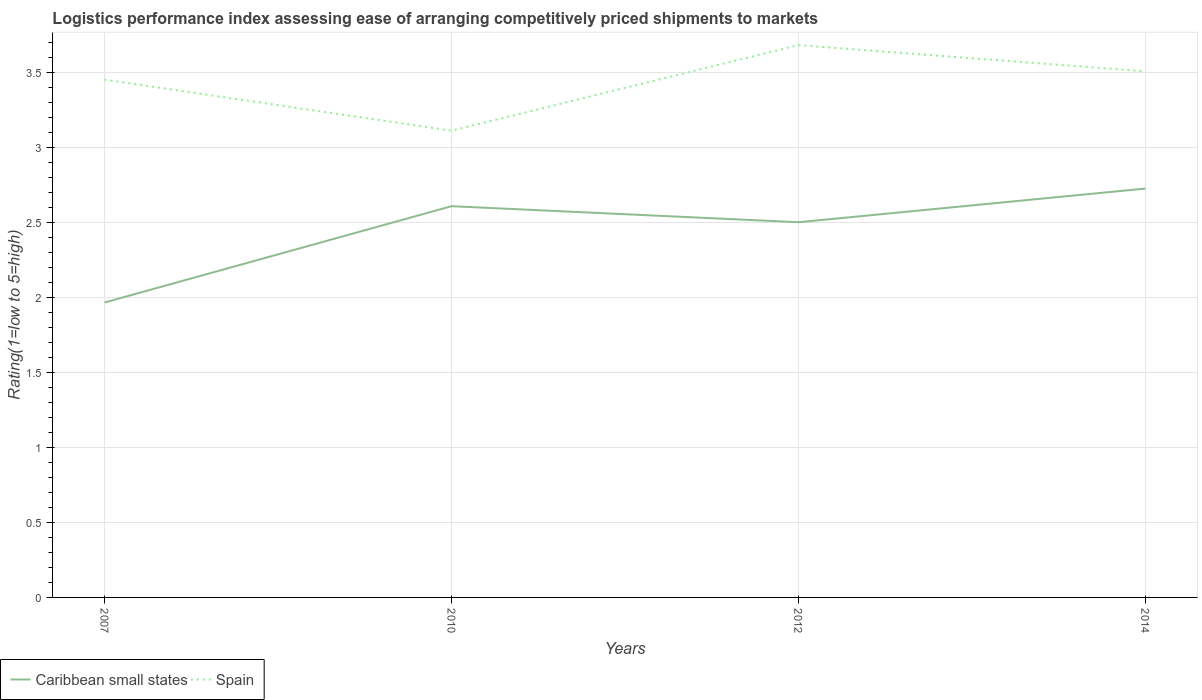How many different coloured lines are there?
Ensure brevity in your answer.  2. Is the number of lines equal to the number of legend labels?
Offer a very short reply. Yes. Across all years, what is the maximum Logistic performance index in Spain?
Ensure brevity in your answer.  3.11. In which year was the Logistic performance index in Spain maximum?
Offer a terse response. 2010. What is the total Logistic performance index in Caribbean small states in the graph?
Your answer should be compact. -0.22. What is the difference between the highest and the second highest Logistic performance index in Caribbean small states?
Your answer should be compact. 0.76. What is the difference between the highest and the lowest Logistic performance index in Caribbean small states?
Offer a very short reply. 3. Is the Logistic performance index in Spain strictly greater than the Logistic performance index in Caribbean small states over the years?
Make the answer very short. No. Are the values on the major ticks of Y-axis written in scientific E-notation?
Give a very brief answer. No. Where does the legend appear in the graph?
Ensure brevity in your answer.  Bottom left. How many legend labels are there?
Provide a short and direct response. 2. How are the legend labels stacked?
Provide a succinct answer. Horizontal. What is the title of the graph?
Give a very brief answer. Logistics performance index assessing ease of arranging competitively priced shipments to markets. Does "Puerto Rico" appear as one of the legend labels in the graph?
Provide a short and direct response. No. What is the label or title of the X-axis?
Provide a succinct answer. Years. What is the label or title of the Y-axis?
Offer a terse response. Rating(1=low to 5=high). What is the Rating(1=low to 5=high) in Caribbean small states in 2007?
Make the answer very short. 1.97. What is the Rating(1=low to 5=high) of Spain in 2007?
Offer a terse response. 3.45. What is the Rating(1=low to 5=high) in Caribbean small states in 2010?
Keep it short and to the point. 2.61. What is the Rating(1=low to 5=high) in Spain in 2010?
Offer a very short reply. 3.11. What is the Rating(1=low to 5=high) in Caribbean small states in 2012?
Keep it short and to the point. 2.5. What is the Rating(1=low to 5=high) of Spain in 2012?
Provide a short and direct response. 3.68. What is the Rating(1=low to 5=high) in Caribbean small states in 2014?
Offer a terse response. 2.72. What is the Rating(1=low to 5=high) in Spain in 2014?
Ensure brevity in your answer.  3.51. Across all years, what is the maximum Rating(1=low to 5=high) in Caribbean small states?
Offer a very short reply. 2.72. Across all years, what is the maximum Rating(1=low to 5=high) of Spain?
Ensure brevity in your answer.  3.68. Across all years, what is the minimum Rating(1=low to 5=high) in Caribbean small states?
Keep it short and to the point. 1.97. Across all years, what is the minimum Rating(1=low to 5=high) in Spain?
Ensure brevity in your answer.  3.11. What is the total Rating(1=low to 5=high) in Caribbean small states in the graph?
Offer a very short reply. 9.8. What is the total Rating(1=low to 5=high) in Spain in the graph?
Offer a terse response. 13.75. What is the difference between the Rating(1=low to 5=high) in Caribbean small states in 2007 and that in 2010?
Give a very brief answer. -0.64. What is the difference between the Rating(1=low to 5=high) in Spain in 2007 and that in 2010?
Keep it short and to the point. 0.34. What is the difference between the Rating(1=low to 5=high) in Caribbean small states in 2007 and that in 2012?
Your answer should be compact. -0.54. What is the difference between the Rating(1=low to 5=high) of Spain in 2007 and that in 2012?
Your answer should be very brief. -0.23. What is the difference between the Rating(1=low to 5=high) of Caribbean small states in 2007 and that in 2014?
Keep it short and to the point. -0.76. What is the difference between the Rating(1=low to 5=high) of Spain in 2007 and that in 2014?
Provide a short and direct response. -0.06. What is the difference between the Rating(1=low to 5=high) of Caribbean small states in 2010 and that in 2012?
Make the answer very short. 0.11. What is the difference between the Rating(1=low to 5=high) in Spain in 2010 and that in 2012?
Offer a very short reply. -0.57. What is the difference between the Rating(1=low to 5=high) in Caribbean small states in 2010 and that in 2014?
Your answer should be very brief. -0.12. What is the difference between the Rating(1=low to 5=high) in Spain in 2010 and that in 2014?
Make the answer very short. -0.4. What is the difference between the Rating(1=low to 5=high) in Caribbean small states in 2012 and that in 2014?
Your answer should be very brief. -0.22. What is the difference between the Rating(1=low to 5=high) in Spain in 2012 and that in 2014?
Keep it short and to the point. 0.17. What is the difference between the Rating(1=low to 5=high) in Caribbean small states in 2007 and the Rating(1=low to 5=high) in Spain in 2010?
Make the answer very short. -1.15. What is the difference between the Rating(1=low to 5=high) in Caribbean small states in 2007 and the Rating(1=low to 5=high) in Spain in 2012?
Provide a succinct answer. -1.72. What is the difference between the Rating(1=low to 5=high) of Caribbean small states in 2007 and the Rating(1=low to 5=high) of Spain in 2014?
Ensure brevity in your answer.  -1.54. What is the difference between the Rating(1=low to 5=high) in Caribbean small states in 2010 and the Rating(1=low to 5=high) in Spain in 2012?
Your answer should be very brief. -1.07. What is the difference between the Rating(1=low to 5=high) in Caribbean small states in 2010 and the Rating(1=low to 5=high) in Spain in 2014?
Ensure brevity in your answer.  -0.9. What is the difference between the Rating(1=low to 5=high) of Caribbean small states in 2012 and the Rating(1=low to 5=high) of Spain in 2014?
Your answer should be compact. -1.01. What is the average Rating(1=low to 5=high) in Caribbean small states per year?
Ensure brevity in your answer.  2.45. What is the average Rating(1=low to 5=high) of Spain per year?
Provide a short and direct response. 3.44. In the year 2007, what is the difference between the Rating(1=low to 5=high) in Caribbean small states and Rating(1=low to 5=high) in Spain?
Offer a very short reply. -1.49. In the year 2010, what is the difference between the Rating(1=low to 5=high) of Caribbean small states and Rating(1=low to 5=high) of Spain?
Offer a terse response. -0.5. In the year 2012, what is the difference between the Rating(1=low to 5=high) of Caribbean small states and Rating(1=low to 5=high) of Spain?
Offer a terse response. -1.18. In the year 2014, what is the difference between the Rating(1=low to 5=high) of Caribbean small states and Rating(1=low to 5=high) of Spain?
Provide a succinct answer. -0.78. What is the ratio of the Rating(1=low to 5=high) in Caribbean small states in 2007 to that in 2010?
Your answer should be compact. 0.75. What is the ratio of the Rating(1=low to 5=high) of Spain in 2007 to that in 2010?
Provide a short and direct response. 1.11. What is the ratio of the Rating(1=low to 5=high) of Caribbean small states in 2007 to that in 2012?
Your response must be concise. 0.79. What is the ratio of the Rating(1=low to 5=high) in Caribbean small states in 2007 to that in 2014?
Offer a terse response. 0.72. What is the ratio of the Rating(1=low to 5=high) in Spain in 2007 to that in 2014?
Give a very brief answer. 0.98. What is the ratio of the Rating(1=low to 5=high) of Caribbean small states in 2010 to that in 2012?
Offer a very short reply. 1.04. What is the ratio of the Rating(1=low to 5=high) of Spain in 2010 to that in 2012?
Offer a terse response. 0.85. What is the ratio of the Rating(1=low to 5=high) of Caribbean small states in 2010 to that in 2014?
Your response must be concise. 0.96. What is the ratio of the Rating(1=low to 5=high) of Spain in 2010 to that in 2014?
Offer a terse response. 0.89. What is the ratio of the Rating(1=low to 5=high) in Caribbean small states in 2012 to that in 2014?
Provide a succinct answer. 0.92. What is the ratio of the Rating(1=low to 5=high) in Spain in 2012 to that in 2014?
Make the answer very short. 1.05. What is the difference between the highest and the second highest Rating(1=low to 5=high) in Caribbean small states?
Your response must be concise. 0.12. What is the difference between the highest and the second highest Rating(1=low to 5=high) in Spain?
Your answer should be very brief. 0.17. What is the difference between the highest and the lowest Rating(1=low to 5=high) of Caribbean small states?
Give a very brief answer. 0.76. What is the difference between the highest and the lowest Rating(1=low to 5=high) of Spain?
Your answer should be compact. 0.57. 